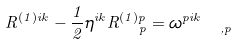Convert formula to latex. <formula><loc_0><loc_0><loc_500><loc_500>R ^ { ( 1 ) i k } - \frac { 1 } { 2 } \eta ^ { i k } R _ { \text { \quad } p } ^ { ( 1 ) p } = { \omega } _ { \quad , p } ^ { p i k }</formula> 